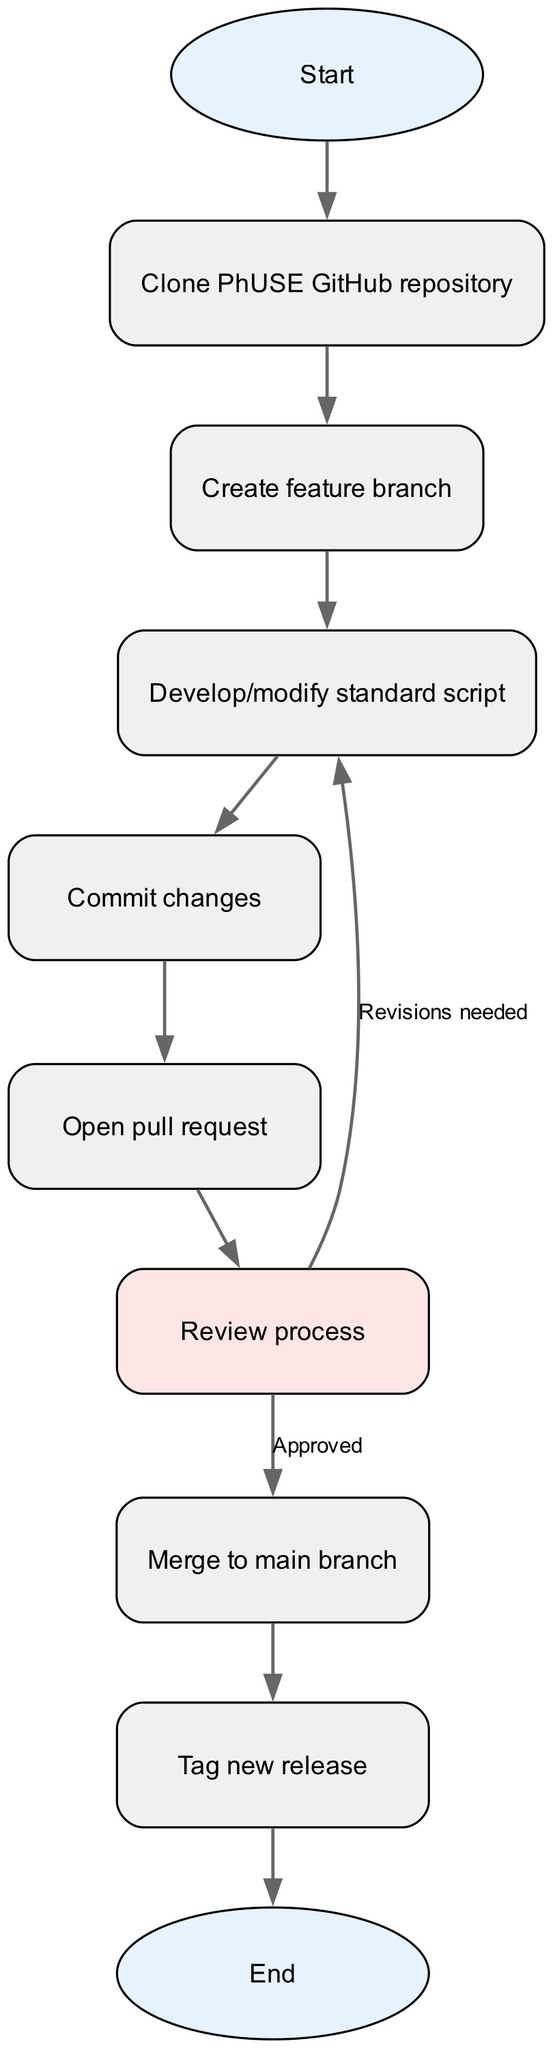What is the first node in the diagram? The first node is labeled "Start," which initiates the flow of the process. It is the only node that precedes all other nodes in the flow chart.
Answer: Start What follows immediately after "Clone PhUSE GitHub repository"? After "Clone PhUSE GitHub repository," the next node is "Create feature branch," indicating sequential steps in the process.
Answer: Create feature branch How many nodes are there in total? By counting all unique nodes listed in the diagram, we find there are ten nodes in total, making a complete path from start to finish.
Answer: 10 What happens to the flow when the review process needs revisions? If the review process identifies that revisions are needed, the flow goes back to "Develop/modify standard script," indicating that corrections must be made before proceeding further.
Answer: Develop/modify standard script Which node is tagged as the final step in the process? The final node is labeled "End," which signifies the completion of the entire version control and release management process depicted in the flow chart.
Answer: End Which node provides a condition that leads to two different paths? The "Review process" node, where the decision is made between "Approved" leading to "Merge to main branch" or "Revisions needed" leading back to "Develop/modify standard script."
Answer: Review process What is tagged after merging to the main branch? After merging to the main branch, the next step is to "Tag new release," showcasing a critical step in finalizing changes.
Answer: Tag new release How many edges are depicted in the flow diagram? By counting the connections between all the nodes in the flow chart, we discover a total of nine edges that illustrate the direct relationships between each step in the process.
Answer: 9 What action is taken after committing changes? Following "Commit changes," the action taken is to "Open pull request," indicating the step where changes are proposed for integration into the main project.
Answer: Open pull request 